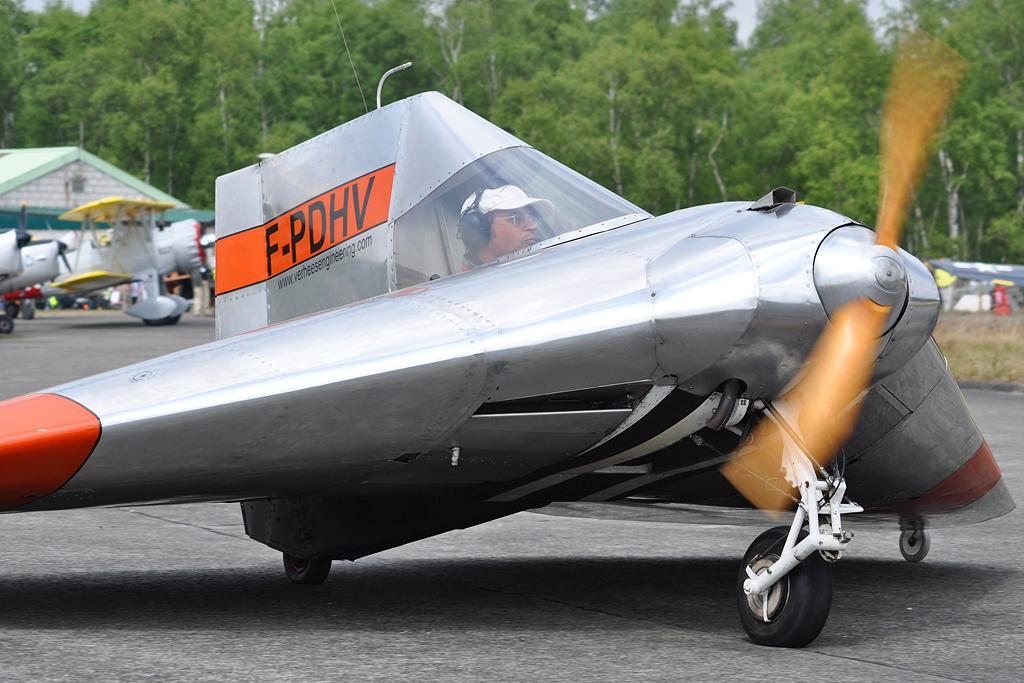<image>
Summarize the visual content of the image. Man in a tiny plane with the license number F-PDHV. 